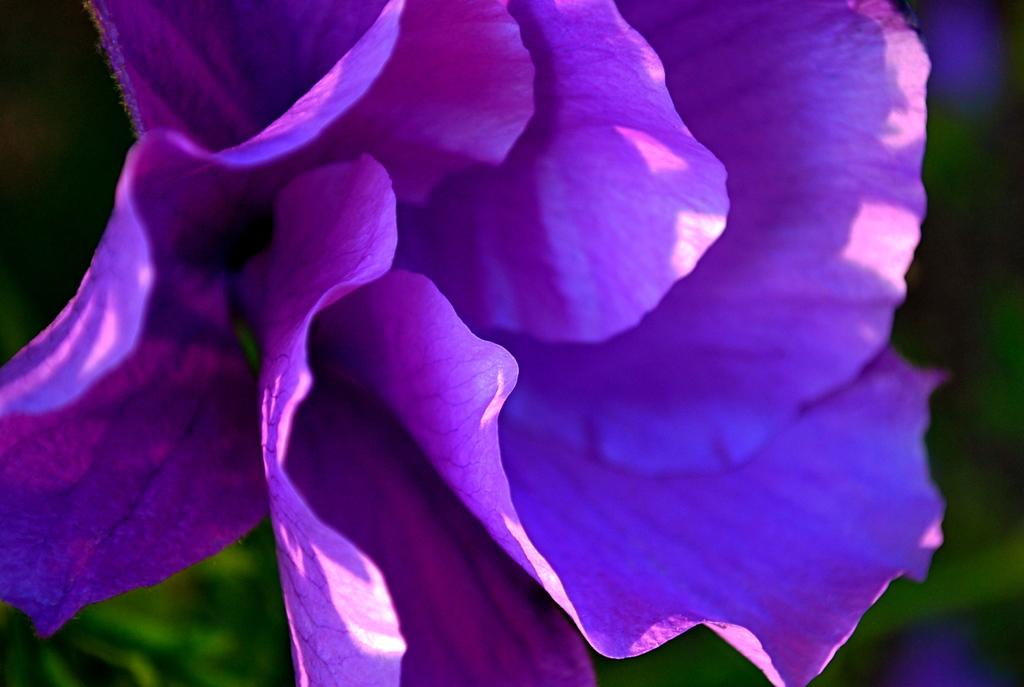Where was the image taken? The image was taken outdoors. Can you describe the background of the image? The background of the image is slightly blurred. What type of plant can be seen in the image? There is a plant in the image. What specific feature of the plant is visible? There is a flower in the image. What color is the flower? The flower is purple in color. What type of punishment is being administered to the birds in the image? There are no birds present in the image, so no punishment is being administered. What type of feast is being prepared in the image? There is no feast being prepared in the image; the focus is on a plant with a purple flower. 